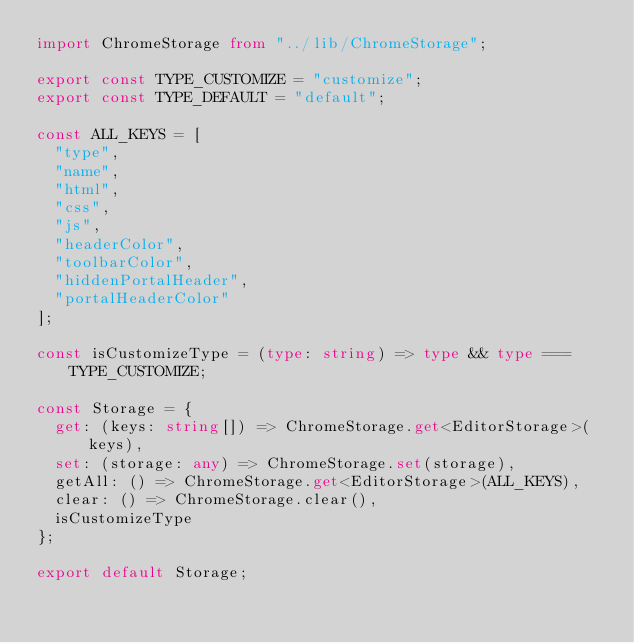<code> <loc_0><loc_0><loc_500><loc_500><_TypeScript_>import ChromeStorage from "../lib/ChromeStorage";

export const TYPE_CUSTOMIZE = "customize";
export const TYPE_DEFAULT = "default";

const ALL_KEYS = [
  "type",
  "name",
  "html",
  "css",
  "js",
  "headerColor",
  "toolbarColor",
  "hiddenPortalHeader",
  "portalHeaderColor"
];

const isCustomizeType = (type: string) => type && type === TYPE_CUSTOMIZE;

const Storage = {
  get: (keys: string[]) => ChromeStorage.get<EditorStorage>(keys),
  set: (storage: any) => ChromeStorage.set(storage),
  getAll: () => ChromeStorage.get<EditorStorage>(ALL_KEYS),
  clear: () => ChromeStorage.clear(),
  isCustomizeType
};

export default Storage;
</code> 